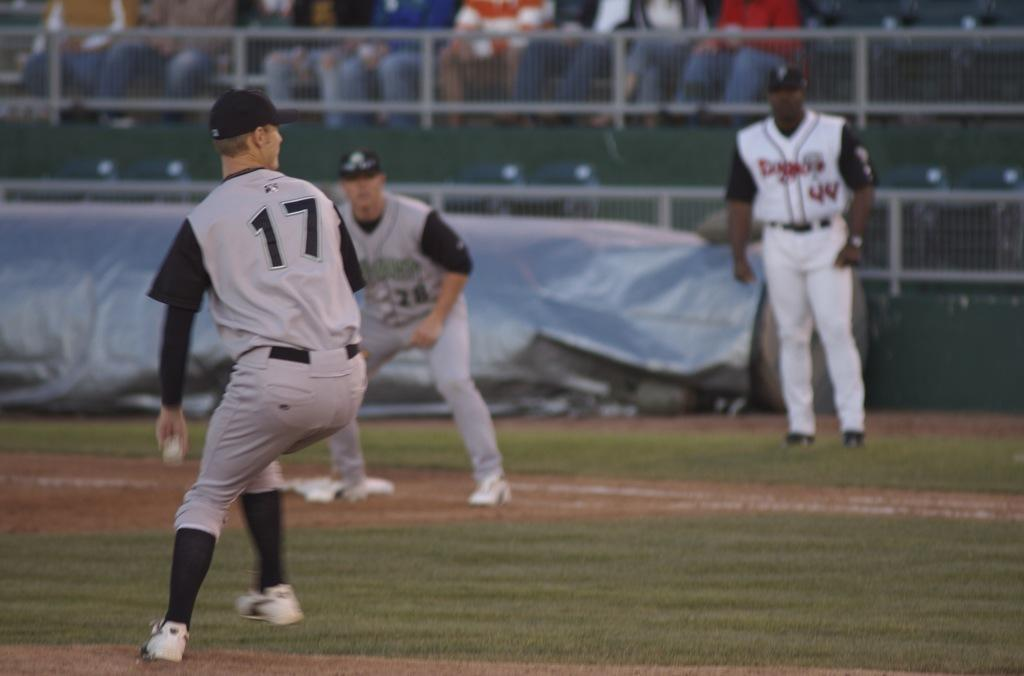<image>
Share a concise interpretation of the image provided. a player pitching a ball with the number 17 on 